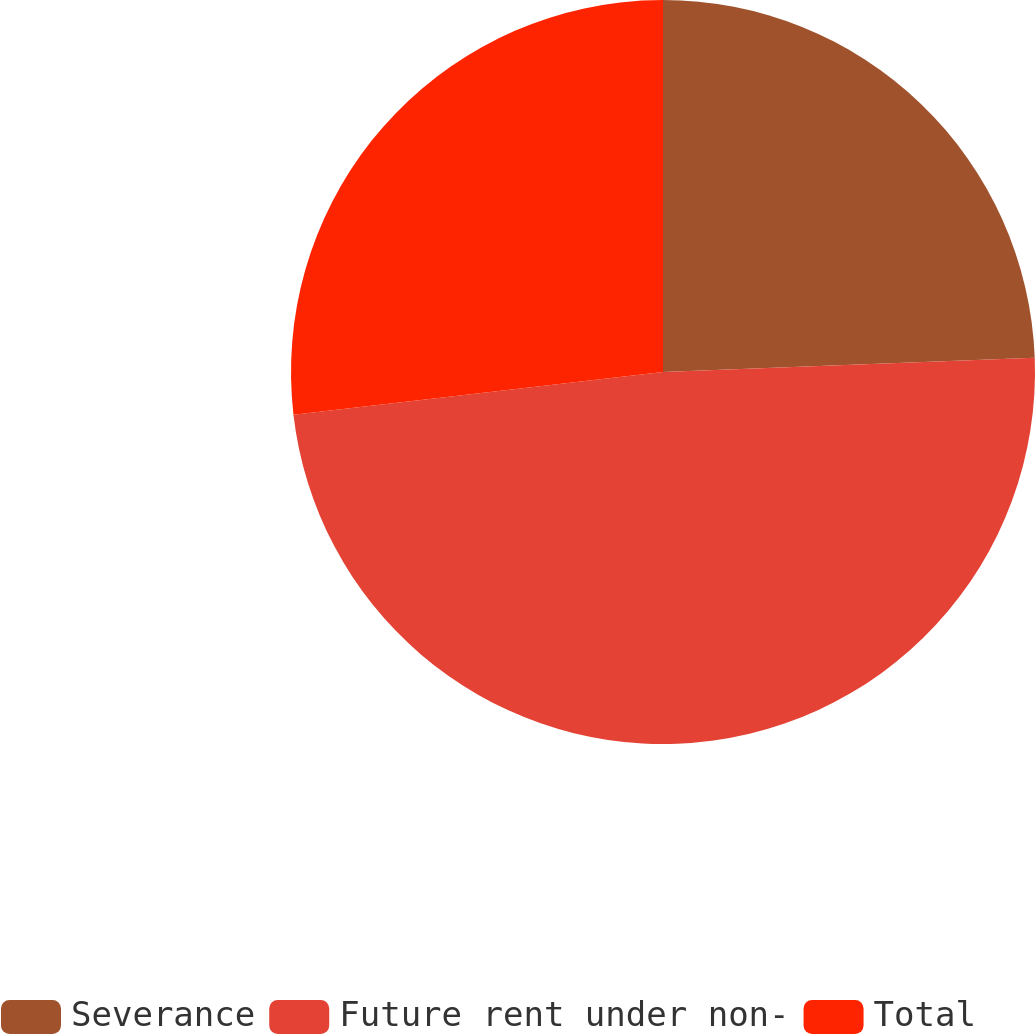<chart> <loc_0><loc_0><loc_500><loc_500><pie_chart><fcel>Severance<fcel>Future rent under non-<fcel>Total<nl><fcel>24.39%<fcel>48.78%<fcel>26.83%<nl></chart> 